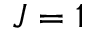Convert formula to latex. <formula><loc_0><loc_0><loc_500><loc_500>J = 1</formula> 